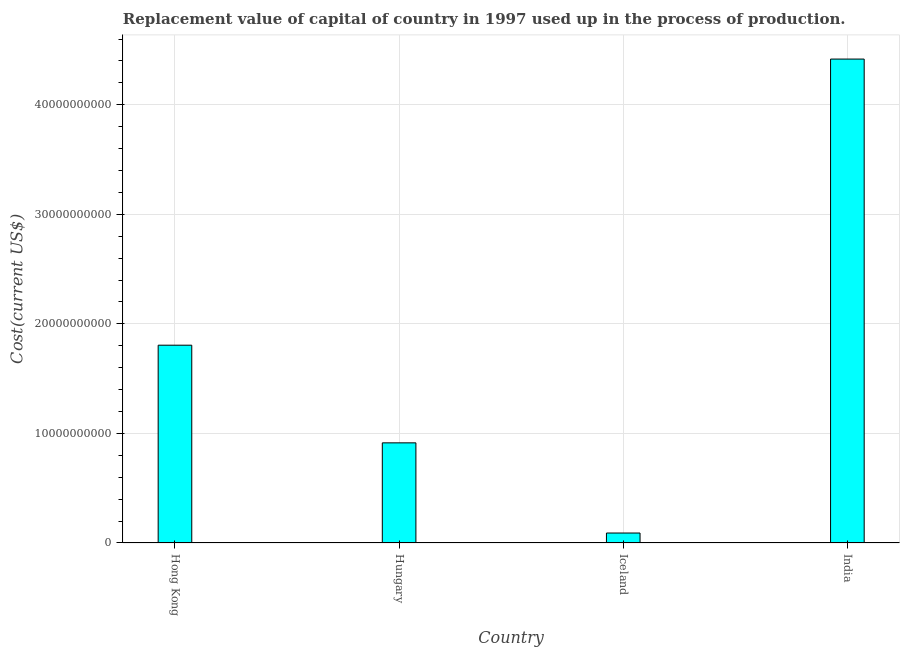Does the graph contain any zero values?
Provide a succinct answer. No. Does the graph contain grids?
Your answer should be very brief. Yes. What is the title of the graph?
Provide a succinct answer. Replacement value of capital of country in 1997 used up in the process of production. What is the label or title of the X-axis?
Your answer should be very brief. Country. What is the label or title of the Y-axis?
Your answer should be compact. Cost(current US$). What is the consumption of fixed capital in Iceland?
Offer a very short reply. 9.10e+08. Across all countries, what is the maximum consumption of fixed capital?
Make the answer very short. 4.42e+1. Across all countries, what is the minimum consumption of fixed capital?
Provide a short and direct response. 9.10e+08. What is the sum of the consumption of fixed capital?
Your answer should be compact. 7.23e+1. What is the difference between the consumption of fixed capital in Hong Kong and Iceland?
Your answer should be very brief. 1.71e+1. What is the average consumption of fixed capital per country?
Give a very brief answer. 1.81e+1. What is the median consumption of fixed capital?
Offer a very short reply. 1.36e+1. What is the ratio of the consumption of fixed capital in Hungary to that in Iceland?
Offer a very short reply. 10.05. What is the difference between the highest and the second highest consumption of fixed capital?
Give a very brief answer. 2.61e+1. Is the sum of the consumption of fixed capital in Hungary and Iceland greater than the maximum consumption of fixed capital across all countries?
Keep it short and to the point. No. What is the difference between the highest and the lowest consumption of fixed capital?
Ensure brevity in your answer.  4.33e+1. What is the difference between two consecutive major ticks on the Y-axis?
Provide a short and direct response. 1.00e+1. Are the values on the major ticks of Y-axis written in scientific E-notation?
Provide a short and direct response. No. What is the Cost(current US$) of Hong Kong?
Your answer should be compact. 1.81e+1. What is the Cost(current US$) of Hungary?
Provide a succinct answer. 9.14e+09. What is the Cost(current US$) of Iceland?
Ensure brevity in your answer.  9.10e+08. What is the Cost(current US$) in India?
Ensure brevity in your answer.  4.42e+1. What is the difference between the Cost(current US$) in Hong Kong and Hungary?
Provide a succinct answer. 8.91e+09. What is the difference between the Cost(current US$) in Hong Kong and Iceland?
Your answer should be compact. 1.71e+1. What is the difference between the Cost(current US$) in Hong Kong and India?
Provide a short and direct response. -2.61e+1. What is the difference between the Cost(current US$) in Hungary and Iceland?
Give a very brief answer. 8.23e+09. What is the difference between the Cost(current US$) in Hungary and India?
Your answer should be very brief. -3.50e+1. What is the difference between the Cost(current US$) in Iceland and India?
Give a very brief answer. -4.33e+1. What is the ratio of the Cost(current US$) in Hong Kong to that in Hungary?
Give a very brief answer. 1.98. What is the ratio of the Cost(current US$) in Hong Kong to that in Iceland?
Your answer should be compact. 19.84. What is the ratio of the Cost(current US$) in Hong Kong to that in India?
Your response must be concise. 0.41. What is the ratio of the Cost(current US$) in Hungary to that in Iceland?
Your response must be concise. 10.05. What is the ratio of the Cost(current US$) in Hungary to that in India?
Your answer should be very brief. 0.21. What is the ratio of the Cost(current US$) in Iceland to that in India?
Offer a terse response. 0.02. 